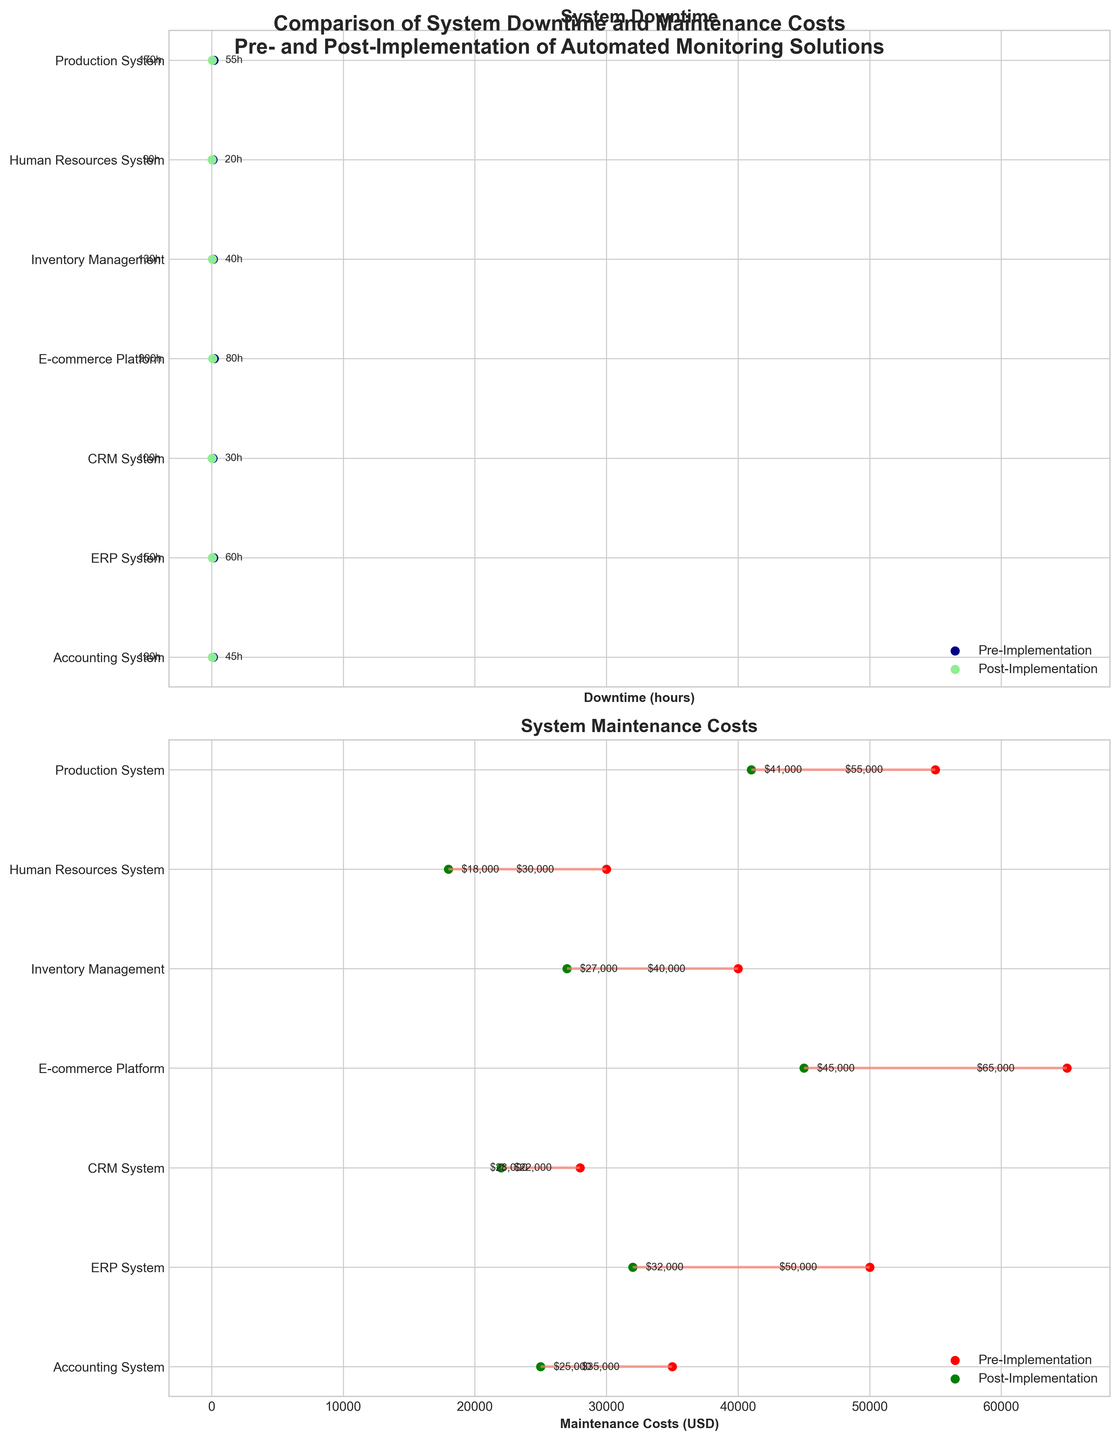What is the title of the figure? The title of the figure is located at the top and provides an overview of what the figure represents. It says: "Comparison of System Downtime and Maintenance Costs Pre- and Post-Implementation of Automated Monitoring Solutions".
Answer: Comparison of System Downtime and Maintenance Costs Pre- and Post-Implementation of Automated Monitoring Solutions Which system showed the largest reduction in downtime after the implementation of automated monitoring solutions? To find the system with the largest reduction in downtime, calculate the difference between pre- and post-implementation downtime for each system. The Human Resources System had a reduction from 90 hours to 20 hours, which equals 70 hours. This is the largest reduction among all systems.
Answer: Human Resources System What were the maintenance costs of the E-commerce Platform before and after the implementation? The maintenance costs for the E-commerce Platform can be directly read from the plotted points corresponding to this system. Before implementation, it was $65,000, and after implementation, it was $45,000.
Answer: $65,000 (pre), $45,000 (post) Which system had the lowest maintenance costs post-implementation? To determine the system with the lowest post-implementation maintenance costs, look at the green dots representing post-implementation maintenance costs on the lower plot. The Human Resources System had the lowest post-implementation cost at $18,000.
Answer: Human Resources System How much did the downtime for the ERP System decrease by after the implementation? For the ERP System, the downtime before implementation was 150 hours, and the downtime after implementation was 60 hours. The decrease in downtime is calculated as 150 - 60 = 90 hours.
Answer: 90 hours Which system had the smallest change in maintenance costs after the implementation? To find the system with the smallest change in maintenance costs, calculate the difference between pre- and post-implementation costs for each system. The Accounting System had a change from $35,000 to $25,000, which is a difference of $10,000, the smallest among all systems.
Answer: Accounting System What is the average pre-implementation downtime across all systems? To calculate the average pre-implementation downtime, sum the pre-implementation downtime values of all systems (120 + 150 + 100 + 200 + 130 + 90 + 170 = 960) and divide by the number of systems (7). The average is 960 / 7 = approximately 137.14 hours.
Answer: 137.14 hours Compare the total maintenance costs post-implementation across all systems to the total pre-implementation costs. What is the total reduction in costs? First, sum the pre-implementation costs ($35,000 + $50,000 + $28,000 + $65,000 + $40,000 + $30,000 + $55,000 = $303,000) and the post-implementation costs ($25,000 + $32,000 + $22,000 + $45,000 + $27,000 + $18,000 + $41,000 = $210,000). The total reduction in costs is $303,000 - $210,000 = $93,000.
Answer: $93,000 How does the downtime reduction of the CRM System compare to that of the Accounting System? The CRM System reduced downtime from 100 hours to 30 hours (100 - 30 = 70 hours reduction). The Accounting System reduced downtime from 120 hours to 45 hours (120 - 45 = 75 hours reduction). Comparing the two, the Accounting System had a 5-hour greater reduction in downtime (75 - 70 = 5 hours).
Answer: Accounting System reduced 5 hours more 